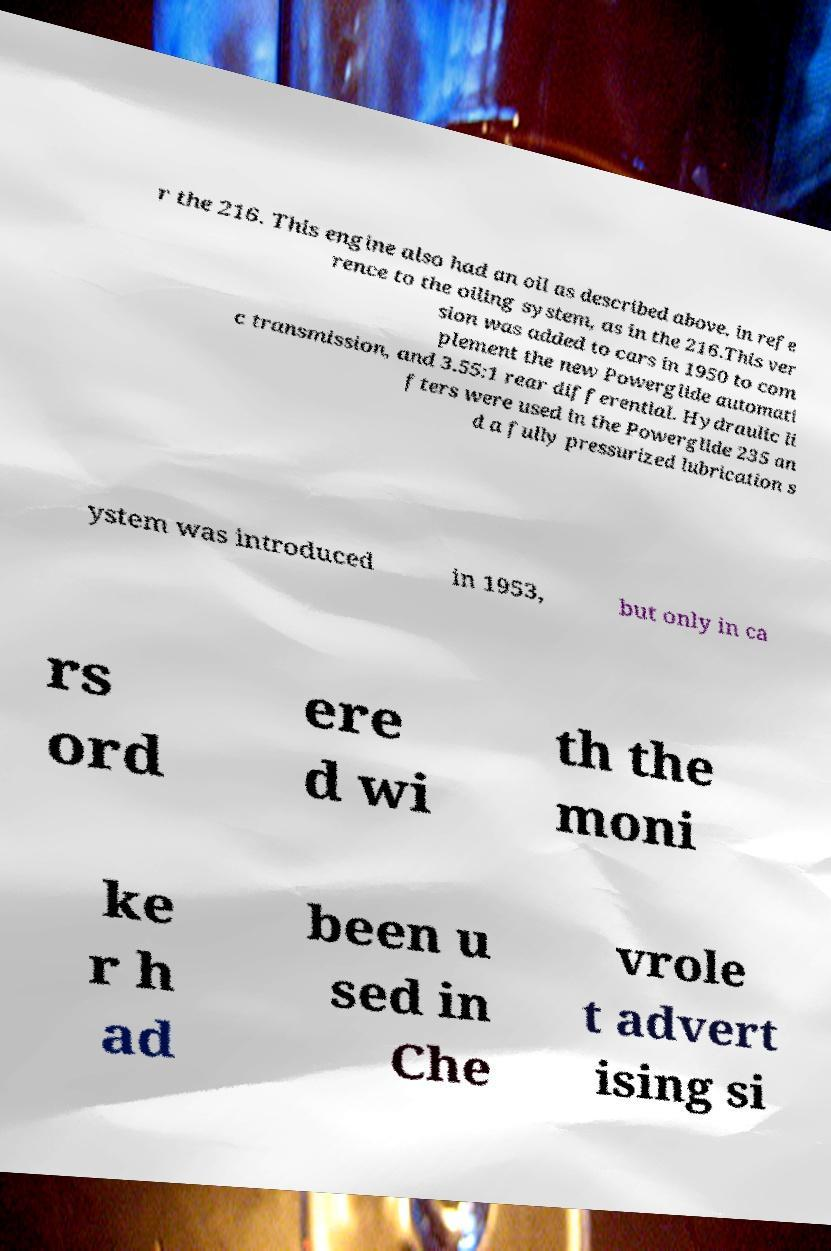For documentation purposes, I need the text within this image transcribed. Could you provide that? r the 216. This engine also had an oil as described above, in refe rence to the oiling system, as in the 216.This ver sion was added to cars in 1950 to com plement the new Powerglide automati c transmission, and 3.55:1 rear differential. Hydraulic li fters were used in the Powerglide 235 an d a fully pressurized lubrication s ystem was introduced in 1953, but only in ca rs ord ere d wi th the moni ke r h ad been u sed in Che vrole t advert ising si 